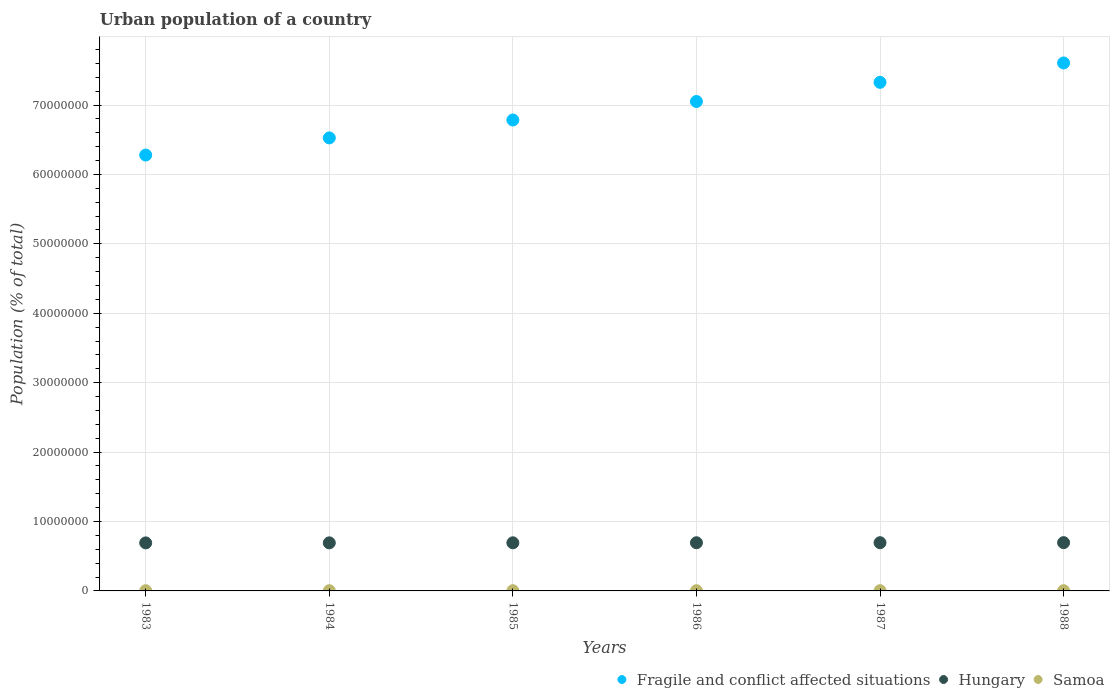How many different coloured dotlines are there?
Provide a succinct answer. 3. Is the number of dotlines equal to the number of legend labels?
Provide a short and direct response. Yes. What is the urban population in Hungary in 1984?
Offer a very short reply. 6.93e+06. Across all years, what is the maximum urban population in Hungary?
Your answer should be very brief. 6.95e+06. Across all years, what is the minimum urban population in Hungary?
Offer a very short reply. 6.92e+06. In which year was the urban population in Samoa maximum?
Provide a succinct answer. 1988. What is the total urban population in Samoa in the graph?
Keep it short and to the point. 2.04e+05. What is the difference between the urban population in Fragile and conflict affected situations in 1985 and that in 1986?
Your answer should be very brief. -2.67e+06. What is the difference between the urban population in Fragile and conflict affected situations in 1985 and the urban population in Samoa in 1986?
Provide a short and direct response. 6.78e+07. What is the average urban population in Hungary per year?
Make the answer very short. 6.94e+06. In the year 1983, what is the difference between the urban population in Fragile and conflict affected situations and urban population in Hungary?
Your response must be concise. 5.59e+07. In how many years, is the urban population in Samoa greater than 16000000 %?
Give a very brief answer. 0. What is the ratio of the urban population in Fragile and conflict affected situations in 1986 to that in 1987?
Ensure brevity in your answer.  0.96. What is the difference between the highest and the second highest urban population in Hungary?
Offer a terse response. 8329. What is the difference between the highest and the lowest urban population in Samoa?
Offer a terse response. 645. In how many years, is the urban population in Hungary greater than the average urban population in Hungary taken over all years?
Keep it short and to the point. 3. Is the sum of the urban population in Fragile and conflict affected situations in 1983 and 1984 greater than the maximum urban population in Samoa across all years?
Your answer should be compact. Yes. Does the urban population in Hungary monotonically increase over the years?
Provide a short and direct response. Yes. Is the urban population in Fragile and conflict affected situations strictly less than the urban population in Hungary over the years?
Your answer should be very brief. No. How many dotlines are there?
Ensure brevity in your answer.  3. How many years are there in the graph?
Your answer should be compact. 6. What is the difference between two consecutive major ticks on the Y-axis?
Give a very brief answer. 1.00e+07. Does the graph contain any zero values?
Your answer should be very brief. No. Does the graph contain grids?
Provide a short and direct response. Yes. What is the title of the graph?
Provide a succinct answer. Urban population of a country. Does "Netherlands" appear as one of the legend labels in the graph?
Give a very brief answer. No. What is the label or title of the X-axis?
Your answer should be very brief. Years. What is the label or title of the Y-axis?
Keep it short and to the point. Population (% of total). What is the Population (% of total) of Fragile and conflict affected situations in 1983?
Make the answer very short. 6.28e+07. What is the Population (% of total) in Hungary in 1983?
Ensure brevity in your answer.  6.92e+06. What is the Population (% of total) in Samoa in 1983?
Offer a very short reply. 3.36e+04. What is the Population (% of total) of Fragile and conflict affected situations in 1984?
Offer a very short reply. 6.53e+07. What is the Population (% of total) in Hungary in 1984?
Your answer should be compact. 6.93e+06. What is the Population (% of total) in Samoa in 1984?
Offer a terse response. 3.38e+04. What is the Population (% of total) of Fragile and conflict affected situations in 1985?
Offer a terse response. 6.78e+07. What is the Population (% of total) of Hungary in 1985?
Your response must be concise. 6.93e+06. What is the Population (% of total) of Samoa in 1985?
Offer a very short reply. 3.39e+04. What is the Population (% of total) of Fragile and conflict affected situations in 1986?
Give a very brief answer. 7.05e+07. What is the Population (% of total) of Hungary in 1986?
Give a very brief answer. 6.94e+06. What is the Population (% of total) in Samoa in 1986?
Provide a short and direct response. 3.40e+04. What is the Population (% of total) in Fragile and conflict affected situations in 1987?
Your answer should be very brief. 7.33e+07. What is the Population (% of total) of Hungary in 1987?
Your answer should be compact. 6.95e+06. What is the Population (% of total) of Samoa in 1987?
Provide a succinct answer. 3.41e+04. What is the Population (% of total) of Fragile and conflict affected situations in 1988?
Offer a very short reply. 7.61e+07. What is the Population (% of total) in Hungary in 1988?
Your answer should be compact. 6.95e+06. What is the Population (% of total) in Samoa in 1988?
Provide a succinct answer. 3.42e+04. Across all years, what is the maximum Population (% of total) of Fragile and conflict affected situations?
Your response must be concise. 7.61e+07. Across all years, what is the maximum Population (% of total) of Hungary?
Provide a succinct answer. 6.95e+06. Across all years, what is the maximum Population (% of total) in Samoa?
Your answer should be very brief. 3.42e+04. Across all years, what is the minimum Population (% of total) in Fragile and conflict affected situations?
Ensure brevity in your answer.  6.28e+07. Across all years, what is the minimum Population (% of total) of Hungary?
Keep it short and to the point. 6.92e+06. Across all years, what is the minimum Population (% of total) of Samoa?
Offer a terse response. 3.36e+04. What is the total Population (% of total) of Fragile and conflict affected situations in the graph?
Offer a very short reply. 4.16e+08. What is the total Population (% of total) in Hungary in the graph?
Your answer should be very brief. 4.16e+07. What is the total Population (% of total) of Samoa in the graph?
Provide a succinct answer. 2.04e+05. What is the difference between the Population (% of total) in Fragile and conflict affected situations in 1983 and that in 1984?
Your answer should be compact. -2.47e+06. What is the difference between the Population (% of total) in Hungary in 1983 and that in 1984?
Your answer should be very brief. -5477. What is the difference between the Population (% of total) in Samoa in 1983 and that in 1984?
Provide a succinct answer. -191. What is the difference between the Population (% of total) in Fragile and conflict affected situations in 1983 and that in 1985?
Make the answer very short. -5.05e+06. What is the difference between the Population (% of total) in Hungary in 1983 and that in 1985?
Provide a short and direct response. -1.21e+04. What is the difference between the Population (% of total) in Samoa in 1983 and that in 1985?
Keep it short and to the point. -349. What is the difference between the Population (% of total) in Fragile and conflict affected situations in 1983 and that in 1986?
Your answer should be compact. -7.72e+06. What is the difference between the Population (% of total) of Hungary in 1983 and that in 1986?
Provide a succinct answer. -1.93e+04. What is the difference between the Population (% of total) in Samoa in 1983 and that in 1986?
Provide a short and direct response. -468. What is the difference between the Population (% of total) in Fragile and conflict affected situations in 1983 and that in 1987?
Offer a very short reply. -1.05e+07. What is the difference between the Population (% of total) in Hungary in 1983 and that in 1987?
Make the answer very short. -2.66e+04. What is the difference between the Population (% of total) in Samoa in 1983 and that in 1987?
Your response must be concise. -558. What is the difference between the Population (% of total) of Fragile and conflict affected situations in 1983 and that in 1988?
Your answer should be very brief. -1.33e+07. What is the difference between the Population (% of total) of Hungary in 1983 and that in 1988?
Provide a short and direct response. -3.50e+04. What is the difference between the Population (% of total) in Samoa in 1983 and that in 1988?
Your answer should be compact. -645. What is the difference between the Population (% of total) of Fragile and conflict affected situations in 1984 and that in 1985?
Provide a succinct answer. -2.58e+06. What is the difference between the Population (% of total) in Hungary in 1984 and that in 1985?
Offer a very short reply. -6586. What is the difference between the Population (% of total) of Samoa in 1984 and that in 1985?
Offer a very short reply. -158. What is the difference between the Population (% of total) in Fragile and conflict affected situations in 1984 and that in 1986?
Provide a succinct answer. -5.24e+06. What is the difference between the Population (% of total) in Hungary in 1984 and that in 1986?
Provide a succinct answer. -1.38e+04. What is the difference between the Population (% of total) of Samoa in 1984 and that in 1986?
Keep it short and to the point. -277. What is the difference between the Population (% of total) in Fragile and conflict affected situations in 1984 and that in 1987?
Your answer should be very brief. -8.00e+06. What is the difference between the Population (% of total) of Hungary in 1984 and that in 1987?
Your answer should be very brief. -2.12e+04. What is the difference between the Population (% of total) of Samoa in 1984 and that in 1987?
Offer a very short reply. -367. What is the difference between the Population (% of total) in Fragile and conflict affected situations in 1984 and that in 1988?
Ensure brevity in your answer.  -1.08e+07. What is the difference between the Population (% of total) in Hungary in 1984 and that in 1988?
Provide a short and direct response. -2.95e+04. What is the difference between the Population (% of total) of Samoa in 1984 and that in 1988?
Make the answer very short. -454. What is the difference between the Population (% of total) in Fragile and conflict affected situations in 1985 and that in 1986?
Offer a very short reply. -2.67e+06. What is the difference between the Population (% of total) of Hungary in 1985 and that in 1986?
Provide a succinct answer. -7214. What is the difference between the Population (% of total) of Samoa in 1985 and that in 1986?
Give a very brief answer. -119. What is the difference between the Population (% of total) in Fragile and conflict affected situations in 1985 and that in 1987?
Give a very brief answer. -5.43e+06. What is the difference between the Population (% of total) in Hungary in 1985 and that in 1987?
Your answer should be compact. -1.46e+04. What is the difference between the Population (% of total) in Samoa in 1985 and that in 1987?
Offer a terse response. -209. What is the difference between the Population (% of total) of Fragile and conflict affected situations in 1985 and that in 1988?
Give a very brief answer. -8.22e+06. What is the difference between the Population (% of total) in Hungary in 1985 and that in 1988?
Offer a very short reply. -2.29e+04. What is the difference between the Population (% of total) of Samoa in 1985 and that in 1988?
Make the answer very short. -296. What is the difference between the Population (% of total) of Fragile and conflict affected situations in 1986 and that in 1987?
Your response must be concise. -2.76e+06. What is the difference between the Population (% of total) of Hungary in 1986 and that in 1987?
Provide a short and direct response. -7363. What is the difference between the Population (% of total) of Samoa in 1986 and that in 1987?
Give a very brief answer. -90. What is the difference between the Population (% of total) in Fragile and conflict affected situations in 1986 and that in 1988?
Give a very brief answer. -5.55e+06. What is the difference between the Population (% of total) of Hungary in 1986 and that in 1988?
Offer a very short reply. -1.57e+04. What is the difference between the Population (% of total) in Samoa in 1986 and that in 1988?
Offer a very short reply. -177. What is the difference between the Population (% of total) of Fragile and conflict affected situations in 1987 and that in 1988?
Provide a succinct answer. -2.79e+06. What is the difference between the Population (% of total) of Hungary in 1987 and that in 1988?
Provide a short and direct response. -8329. What is the difference between the Population (% of total) in Samoa in 1987 and that in 1988?
Keep it short and to the point. -87. What is the difference between the Population (% of total) of Fragile and conflict affected situations in 1983 and the Population (% of total) of Hungary in 1984?
Offer a very short reply. 5.59e+07. What is the difference between the Population (% of total) of Fragile and conflict affected situations in 1983 and the Population (% of total) of Samoa in 1984?
Your answer should be very brief. 6.28e+07. What is the difference between the Population (% of total) in Hungary in 1983 and the Population (% of total) in Samoa in 1984?
Your answer should be very brief. 6.89e+06. What is the difference between the Population (% of total) in Fragile and conflict affected situations in 1983 and the Population (% of total) in Hungary in 1985?
Your answer should be very brief. 5.59e+07. What is the difference between the Population (% of total) in Fragile and conflict affected situations in 1983 and the Population (% of total) in Samoa in 1985?
Give a very brief answer. 6.28e+07. What is the difference between the Population (% of total) of Hungary in 1983 and the Population (% of total) of Samoa in 1985?
Offer a terse response. 6.89e+06. What is the difference between the Population (% of total) of Fragile and conflict affected situations in 1983 and the Population (% of total) of Hungary in 1986?
Provide a short and direct response. 5.59e+07. What is the difference between the Population (% of total) in Fragile and conflict affected situations in 1983 and the Population (% of total) in Samoa in 1986?
Your answer should be very brief. 6.28e+07. What is the difference between the Population (% of total) in Hungary in 1983 and the Population (% of total) in Samoa in 1986?
Your answer should be very brief. 6.89e+06. What is the difference between the Population (% of total) in Fragile and conflict affected situations in 1983 and the Population (% of total) in Hungary in 1987?
Ensure brevity in your answer.  5.58e+07. What is the difference between the Population (% of total) in Fragile and conflict affected situations in 1983 and the Population (% of total) in Samoa in 1987?
Make the answer very short. 6.28e+07. What is the difference between the Population (% of total) in Hungary in 1983 and the Population (% of total) in Samoa in 1987?
Provide a succinct answer. 6.89e+06. What is the difference between the Population (% of total) in Fragile and conflict affected situations in 1983 and the Population (% of total) in Hungary in 1988?
Keep it short and to the point. 5.58e+07. What is the difference between the Population (% of total) of Fragile and conflict affected situations in 1983 and the Population (% of total) of Samoa in 1988?
Provide a short and direct response. 6.28e+07. What is the difference between the Population (% of total) in Hungary in 1983 and the Population (% of total) in Samoa in 1988?
Give a very brief answer. 6.89e+06. What is the difference between the Population (% of total) in Fragile and conflict affected situations in 1984 and the Population (% of total) in Hungary in 1985?
Give a very brief answer. 5.83e+07. What is the difference between the Population (% of total) of Fragile and conflict affected situations in 1984 and the Population (% of total) of Samoa in 1985?
Ensure brevity in your answer.  6.52e+07. What is the difference between the Population (% of total) in Hungary in 1984 and the Population (% of total) in Samoa in 1985?
Your answer should be compact. 6.89e+06. What is the difference between the Population (% of total) of Fragile and conflict affected situations in 1984 and the Population (% of total) of Hungary in 1986?
Keep it short and to the point. 5.83e+07. What is the difference between the Population (% of total) of Fragile and conflict affected situations in 1984 and the Population (% of total) of Samoa in 1986?
Keep it short and to the point. 6.52e+07. What is the difference between the Population (% of total) in Hungary in 1984 and the Population (% of total) in Samoa in 1986?
Give a very brief answer. 6.89e+06. What is the difference between the Population (% of total) in Fragile and conflict affected situations in 1984 and the Population (% of total) in Hungary in 1987?
Give a very brief answer. 5.83e+07. What is the difference between the Population (% of total) in Fragile and conflict affected situations in 1984 and the Population (% of total) in Samoa in 1987?
Give a very brief answer. 6.52e+07. What is the difference between the Population (% of total) in Hungary in 1984 and the Population (% of total) in Samoa in 1987?
Your answer should be very brief. 6.89e+06. What is the difference between the Population (% of total) in Fragile and conflict affected situations in 1984 and the Population (% of total) in Hungary in 1988?
Your answer should be very brief. 5.83e+07. What is the difference between the Population (% of total) in Fragile and conflict affected situations in 1984 and the Population (% of total) in Samoa in 1988?
Offer a very short reply. 6.52e+07. What is the difference between the Population (% of total) in Hungary in 1984 and the Population (% of total) in Samoa in 1988?
Offer a terse response. 6.89e+06. What is the difference between the Population (% of total) of Fragile and conflict affected situations in 1985 and the Population (% of total) of Hungary in 1986?
Give a very brief answer. 6.09e+07. What is the difference between the Population (% of total) of Fragile and conflict affected situations in 1985 and the Population (% of total) of Samoa in 1986?
Provide a succinct answer. 6.78e+07. What is the difference between the Population (% of total) of Hungary in 1985 and the Population (% of total) of Samoa in 1986?
Ensure brevity in your answer.  6.90e+06. What is the difference between the Population (% of total) in Fragile and conflict affected situations in 1985 and the Population (% of total) in Hungary in 1987?
Keep it short and to the point. 6.09e+07. What is the difference between the Population (% of total) of Fragile and conflict affected situations in 1985 and the Population (% of total) of Samoa in 1987?
Your answer should be compact. 6.78e+07. What is the difference between the Population (% of total) in Hungary in 1985 and the Population (% of total) in Samoa in 1987?
Ensure brevity in your answer.  6.90e+06. What is the difference between the Population (% of total) in Fragile and conflict affected situations in 1985 and the Population (% of total) in Hungary in 1988?
Make the answer very short. 6.09e+07. What is the difference between the Population (% of total) of Fragile and conflict affected situations in 1985 and the Population (% of total) of Samoa in 1988?
Your answer should be compact. 6.78e+07. What is the difference between the Population (% of total) of Hungary in 1985 and the Population (% of total) of Samoa in 1988?
Your answer should be compact. 6.90e+06. What is the difference between the Population (% of total) in Fragile and conflict affected situations in 1986 and the Population (% of total) in Hungary in 1987?
Offer a very short reply. 6.36e+07. What is the difference between the Population (% of total) of Fragile and conflict affected situations in 1986 and the Population (% of total) of Samoa in 1987?
Keep it short and to the point. 7.05e+07. What is the difference between the Population (% of total) of Hungary in 1986 and the Population (% of total) of Samoa in 1987?
Give a very brief answer. 6.90e+06. What is the difference between the Population (% of total) of Fragile and conflict affected situations in 1986 and the Population (% of total) of Hungary in 1988?
Offer a very short reply. 6.36e+07. What is the difference between the Population (% of total) of Fragile and conflict affected situations in 1986 and the Population (% of total) of Samoa in 1988?
Provide a short and direct response. 7.05e+07. What is the difference between the Population (% of total) in Hungary in 1986 and the Population (% of total) in Samoa in 1988?
Provide a succinct answer. 6.90e+06. What is the difference between the Population (% of total) of Fragile and conflict affected situations in 1987 and the Population (% of total) of Hungary in 1988?
Provide a succinct answer. 6.63e+07. What is the difference between the Population (% of total) in Fragile and conflict affected situations in 1987 and the Population (% of total) in Samoa in 1988?
Offer a very short reply. 7.32e+07. What is the difference between the Population (% of total) of Hungary in 1987 and the Population (% of total) of Samoa in 1988?
Your response must be concise. 6.91e+06. What is the average Population (% of total) of Fragile and conflict affected situations per year?
Ensure brevity in your answer.  6.93e+07. What is the average Population (% of total) in Hungary per year?
Give a very brief answer. 6.94e+06. What is the average Population (% of total) in Samoa per year?
Make the answer very short. 3.39e+04. In the year 1983, what is the difference between the Population (% of total) in Fragile and conflict affected situations and Population (% of total) in Hungary?
Offer a terse response. 5.59e+07. In the year 1983, what is the difference between the Population (% of total) in Fragile and conflict affected situations and Population (% of total) in Samoa?
Your response must be concise. 6.28e+07. In the year 1983, what is the difference between the Population (% of total) of Hungary and Population (% of total) of Samoa?
Keep it short and to the point. 6.89e+06. In the year 1984, what is the difference between the Population (% of total) of Fragile and conflict affected situations and Population (% of total) of Hungary?
Offer a very short reply. 5.83e+07. In the year 1984, what is the difference between the Population (% of total) of Fragile and conflict affected situations and Population (% of total) of Samoa?
Offer a very short reply. 6.52e+07. In the year 1984, what is the difference between the Population (% of total) in Hungary and Population (% of total) in Samoa?
Your answer should be very brief. 6.89e+06. In the year 1985, what is the difference between the Population (% of total) in Fragile and conflict affected situations and Population (% of total) in Hungary?
Ensure brevity in your answer.  6.09e+07. In the year 1985, what is the difference between the Population (% of total) in Fragile and conflict affected situations and Population (% of total) in Samoa?
Offer a terse response. 6.78e+07. In the year 1985, what is the difference between the Population (% of total) of Hungary and Population (% of total) of Samoa?
Provide a succinct answer. 6.90e+06. In the year 1986, what is the difference between the Population (% of total) in Fragile and conflict affected situations and Population (% of total) in Hungary?
Your answer should be very brief. 6.36e+07. In the year 1986, what is the difference between the Population (% of total) in Fragile and conflict affected situations and Population (% of total) in Samoa?
Give a very brief answer. 7.05e+07. In the year 1986, what is the difference between the Population (% of total) in Hungary and Population (% of total) in Samoa?
Offer a terse response. 6.90e+06. In the year 1987, what is the difference between the Population (% of total) of Fragile and conflict affected situations and Population (% of total) of Hungary?
Ensure brevity in your answer.  6.63e+07. In the year 1987, what is the difference between the Population (% of total) in Fragile and conflict affected situations and Population (% of total) in Samoa?
Make the answer very short. 7.32e+07. In the year 1987, what is the difference between the Population (% of total) of Hungary and Population (% of total) of Samoa?
Offer a terse response. 6.91e+06. In the year 1988, what is the difference between the Population (% of total) in Fragile and conflict affected situations and Population (% of total) in Hungary?
Offer a very short reply. 6.91e+07. In the year 1988, what is the difference between the Population (% of total) in Fragile and conflict affected situations and Population (% of total) in Samoa?
Give a very brief answer. 7.60e+07. In the year 1988, what is the difference between the Population (% of total) in Hungary and Population (% of total) in Samoa?
Your response must be concise. 6.92e+06. What is the ratio of the Population (% of total) in Fragile and conflict affected situations in 1983 to that in 1984?
Your answer should be very brief. 0.96. What is the ratio of the Population (% of total) of Hungary in 1983 to that in 1984?
Your answer should be compact. 1. What is the ratio of the Population (% of total) of Samoa in 1983 to that in 1984?
Your answer should be compact. 0.99. What is the ratio of the Population (% of total) of Fragile and conflict affected situations in 1983 to that in 1985?
Ensure brevity in your answer.  0.93. What is the ratio of the Population (% of total) in Hungary in 1983 to that in 1985?
Offer a very short reply. 1. What is the ratio of the Population (% of total) in Samoa in 1983 to that in 1985?
Keep it short and to the point. 0.99. What is the ratio of the Population (% of total) in Fragile and conflict affected situations in 1983 to that in 1986?
Give a very brief answer. 0.89. What is the ratio of the Population (% of total) of Samoa in 1983 to that in 1986?
Keep it short and to the point. 0.99. What is the ratio of the Population (% of total) in Fragile and conflict affected situations in 1983 to that in 1987?
Give a very brief answer. 0.86. What is the ratio of the Population (% of total) of Hungary in 1983 to that in 1987?
Provide a succinct answer. 1. What is the ratio of the Population (% of total) of Samoa in 1983 to that in 1987?
Your answer should be compact. 0.98. What is the ratio of the Population (% of total) in Fragile and conflict affected situations in 1983 to that in 1988?
Offer a terse response. 0.83. What is the ratio of the Population (% of total) in Samoa in 1983 to that in 1988?
Give a very brief answer. 0.98. What is the ratio of the Population (% of total) in Fragile and conflict affected situations in 1984 to that in 1986?
Ensure brevity in your answer.  0.93. What is the ratio of the Population (% of total) in Hungary in 1984 to that in 1986?
Ensure brevity in your answer.  1. What is the ratio of the Population (% of total) of Fragile and conflict affected situations in 1984 to that in 1987?
Your answer should be very brief. 0.89. What is the ratio of the Population (% of total) in Hungary in 1984 to that in 1987?
Offer a very short reply. 1. What is the ratio of the Population (% of total) in Fragile and conflict affected situations in 1984 to that in 1988?
Give a very brief answer. 0.86. What is the ratio of the Population (% of total) in Hungary in 1984 to that in 1988?
Your response must be concise. 1. What is the ratio of the Population (% of total) of Samoa in 1984 to that in 1988?
Give a very brief answer. 0.99. What is the ratio of the Population (% of total) of Fragile and conflict affected situations in 1985 to that in 1986?
Offer a very short reply. 0.96. What is the ratio of the Population (% of total) in Fragile and conflict affected situations in 1985 to that in 1987?
Make the answer very short. 0.93. What is the ratio of the Population (% of total) of Hungary in 1985 to that in 1987?
Keep it short and to the point. 1. What is the ratio of the Population (% of total) in Samoa in 1985 to that in 1987?
Your answer should be compact. 0.99. What is the ratio of the Population (% of total) in Fragile and conflict affected situations in 1985 to that in 1988?
Your answer should be compact. 0.89. What is the ratio of the Population (% of total) of Hungary in 1985 to that in 1988?
Your answer should be very brief. 1. What is the ratio of the Population (% of total) of Fragile and conflict affected situations in 1986 to that in 1987?
Keep it short and to the point. 0.96. What is the ratio of the Population (% of total) in Hungary in 1986 to that in 1987?
Make the answer very short. 1. What is the ratio of the Population (% of total) of Fragile and conflict affected situations in 1986 to that in 1988?
Your answer should be very brief. 0.93. What is the ratio of the Population (% of total) in Hungary in 1986 to that in 1988?
Make the answer very short. 1. What is the ratio of the Population (% of total) in Samoa in 1986 to that in 1988?
Make the answer very short. 0.99. What is the ratio of the Population (% of total) in Fragile and conflict affected situations in 1987 to that in 1988?
Offer a terse response. 0.96. What is the difference between the highest and the second highest Population (% of total) of Fragile and conflict affected situations?
Your response must be concise. 2.79e+06. What is the difference between the highest and the second highest Population (% of total) of Hungary?
Provide a short and direct response. 8329. What is the difference between the highest and the lowest Population (% of total) of Fragile and conflict affected situations?
Your response must be concise. 1.33e+07. What is the difference between the highest and the lowest Population (% of total) of Hungary?
Give a very brief answer. 3.50e+04. What is the difference between the highest and the lowest Population (% of total) in Samoa?
Make the answer very short. 645. 